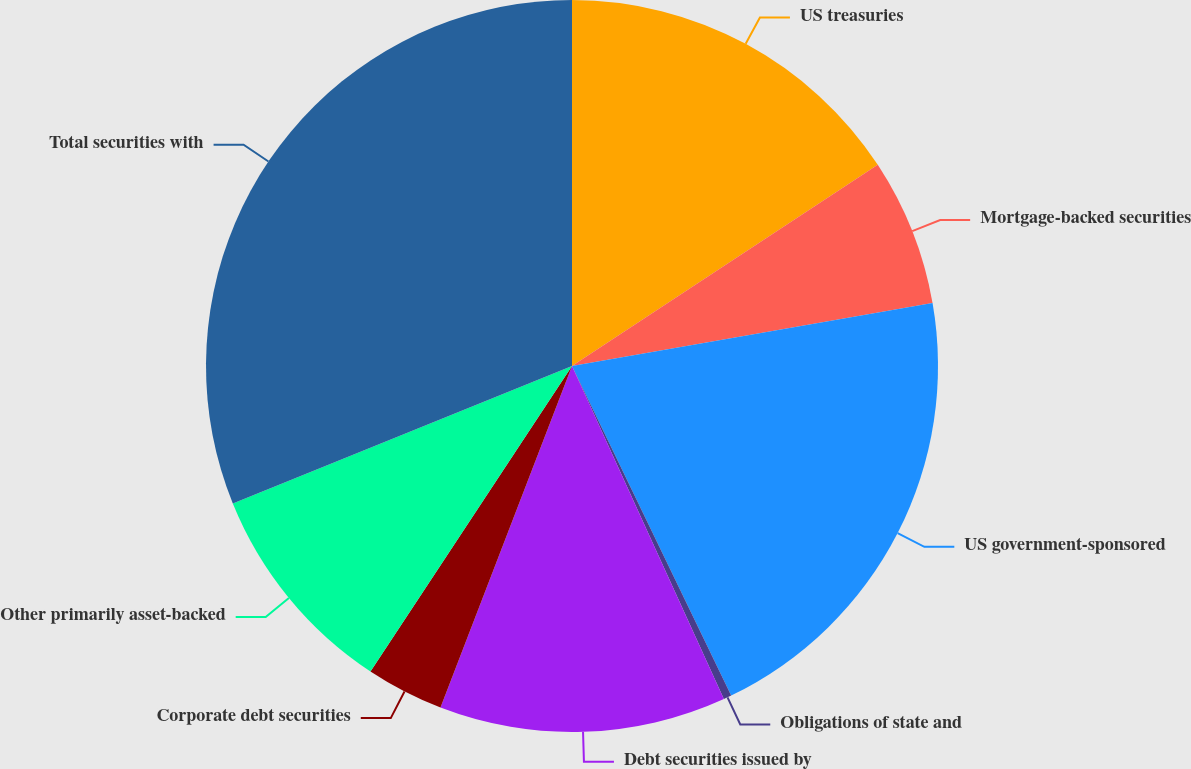Convert chart to OTSL. <chart><loc_0><loc_0><loc_500><loc_500><pie_chart><fcel>US treasuries<fcel>Mortgage-backed securities<fcel>US government-sponsored<fcel>Obligations of state and<fcel>Debt securities issued by<fcel>Corporate debt securities<fcel>Other primarily asset-backed<fcel>Total securities with<nl><fcel>15.74%<fcel>6.51%<fcel>20.59%<fcel>0.35%<fcel>12.66%<fcel>3.43%<fcel>9.59%<fcel>31.13%<nl></chart> 